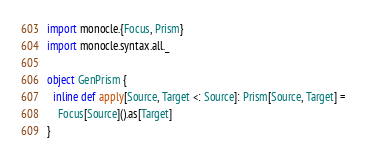Convert code to text. <code><loc_0><loc_0><loc_500><loc_500><_Scala_>import monocle.{Focus, Prism}
import monocle.syntax.all._

object GenPrism {
  inline def apply[Source, Target <: Source]: Prism[Source, Target] =
    Focus[Source]().as[Target]
}</code> 